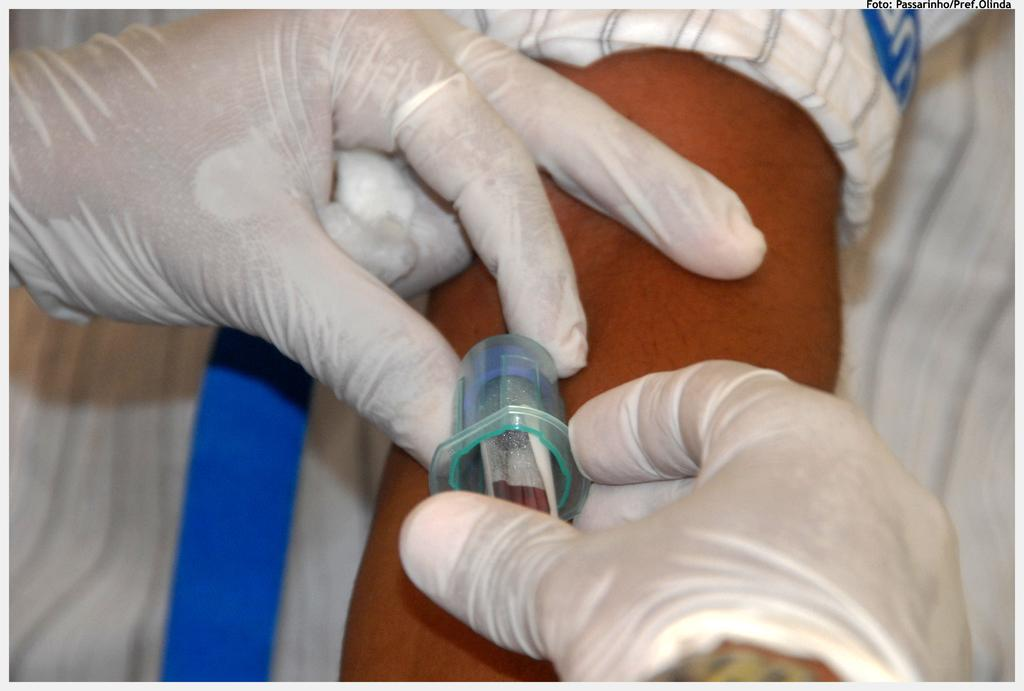What is the person holding in the image? The person is holding a syringe in the image. What else is the person doing with their hands? The person is holding another person's hand. Can you describe the setting of the image? The image may have been taken in a room. What type of icicle can be seen hanging from the syringe in the image? There is no icicle present in the image; it features a person holding a syringe and another person's hand. What substance is being injected into the person's hand by the syringe? The image does not specify the substance being injected, so it cannot be determined from the picture. 